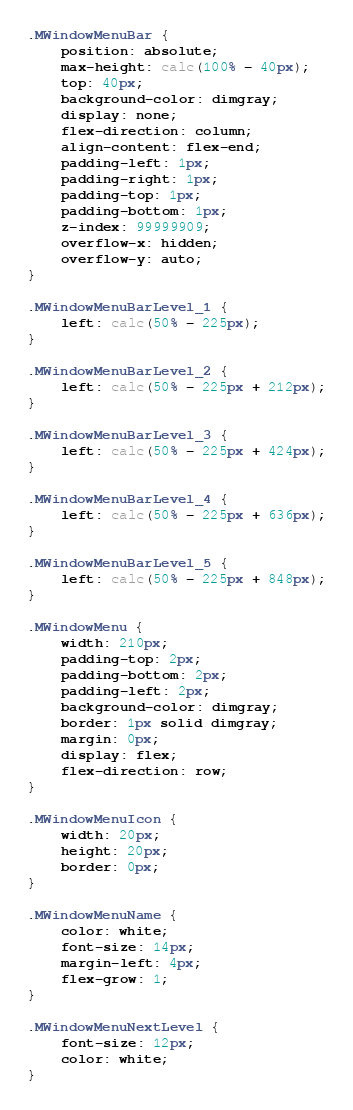Convert code to text. <code><loc_0><loc_0><loc_500><loc_500><_CSS_>.MWindowMenuBar {
	position: absolute;
	max-height: calc(100% - 40px);
	top: 40px;
	background-color: dimgray;
	display: none;
	flex-direction: column;
	align-content: flex-end;
	padding-left: 1px;
	padding-right: 1px;
	padding-top: 1px;
	padding-bottom: 1px;
	z-index: 99999909;
	overflow-x: hidden;
	overflow-y: auto;
}

.MWindowMenuBarLevel_1 {
	left: calc(50% - 225px);
}

.MWindowMenuBarLevel_2 {
	left: calc(50% - 225px + 212px);
}

.MWindowMenuBarLevel_3 {
	left: calc(50% - 225px + 424px);
}

.MWindowMenuBarLevel_4 {
	left: calc(50% - 225px + 636px);
}

.MWindowMenuBarLevel_5 {
	left: calc(50% - 225px + 848px);
}

.MWindowMenu {
	width: 210px;
	padding-top: 2px;
	padding-bottom: 2px;
	padding-left: 2px;
	background-color: dimgray;
	border: 1px solid dimgray;
	margin: 0px;
	display: flex;
	flex-direction: row;
}

.MWindowMenuIcon {
	width: 20px;
	height: 20px;
	border: 0px;
}

.MWindowMenuName {
	color: white;
	font-size: 14px;
	margin-left: 4px; 
	flex-grow: 1;
}

.MWindowMenuNextLevel {
	font-size: 12px; 
	color: white;
}</code> 